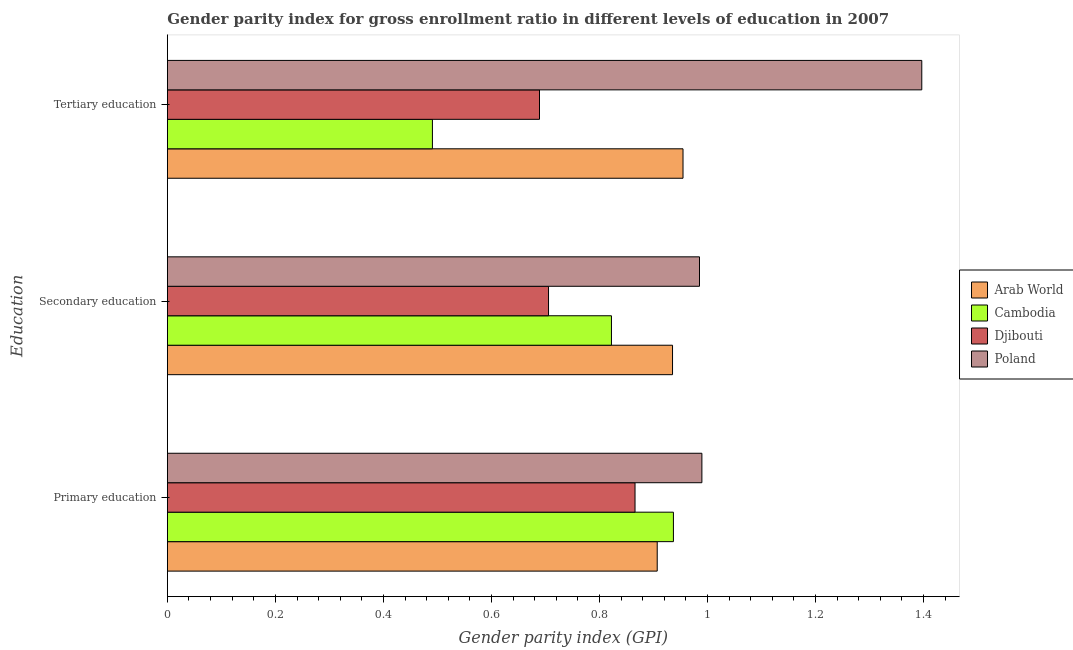How many different coloured bars are there?
Keep it short and to the point. 4. Are the number of bars on each tick of the Y-axis equal?
Provide a succinct answer. Yes. How many bars are there on the 2nd tick from the bottom?
Your response must be concise. 4. What is the label of the 2nd group of bars from the top?
Ensure brevity in your answer.  Secondary education. What is the gender parity index in primary education in Poland?
Ensure brevity in your answer.  0.99. Across all countries, what is the maximum gender parity index in tertiary education?
Provide a succinct answer. 1.4. Across all countries, what is the minimum gender parity index in tertiary education?
Ensure brevity in your answer.  0.49. In which country was the gender parity index in primary education maximum?
Provide a short and direct response. Poland. In which country was the gender parity index in primary education minimum?
Offer a very short reply. Djibouti. What is the total gender parity index in secondary education in the graph?
Make the answer very short. 3.45. What is the difference between the gender parity index in tertiary education in Djibouti and that in Poland?
Offer a terse response. -0.71. What is the difference between the gender parity index in tertiary education in Cambodia and the gender parity index in primary education in Djibouti?
Your answer should be compact. -0.38. What is the average gender parity index in primary education per country?
Offer a terse response. 0.92. What is the difference between the gender parity index in tertiary education and gender parity index in secondary education in Djibouti?
Ensure brevity in your answer.  -0.02. In how many countries, is the gender parity index in secondary education greater than 1.2400000000000002 ?
Your answer should be compact. 0. What is the ratio of the gender parity index in tertiary education in Cambodia to that in Poland?
Provide a succinct answer. 0.35. Is the gender parity index in primary education in Arab World less than that in Djibouti?
Provide a short and direct response. No. What is the difference between the highest and the second highest gender parity index in primary education?
Ensure brevity in your answer.  0.05. What is the difference between the highest and the lowest gender parity index in primary education?
Your answer should be compact. 0.12. In how many countries, is the gender parity index in primary education greater than the average gender parity index in primary education taken over all countries?
Keep it short and to the point. 2. What does the 3rd bar from the top in Primary education represents?
Ensure brevity in your answer.  Cambodia. What does the 1st bar from the bottom in Primary education represents?
Offer a terse response. Arab World. Is it the case that in every country, the sum of the gender parity index in primary education and gender parity index in secondary education is greater than the gender parity index in tertiary education?
Ensure brevity in your answer.  Yes. Does the graph contain any zero values?
Ensure brevity in your answer.  No. Does the graph contain grids?
Provide a short and direct response. No. How many legend labels are there?
Make the answer very short. 4. How are the legend labels stacked?
Provide a succinct answer. Vertical. What is the title of the graph?
Your answer should be compact. Gender parity index for gross enrollment ratio in different levels of education in 2007. What is the label or title of the X-axis?
Give a very brief answer. Gender parity index (GPI). What is the label or title of the Y-axis?
Your response must be concise. Education. What is the Gender parity index (GPI) of Arab World in Primary education?
Ensure brevity in your answer.  0.91. What is the Gender parity index (GPI) of Cambodia in Primary education?
Give a very brief answer. 0.94. What is the Gender parity index (GPI) in Djibouti in Primary education?
Provide a short and direct response. 0.87. What is the Gender parity index (GPI) in Poland in Primary education?
Your answer should be compact. 0.99. What is the Gender parity index (GPI) of Arab World in Secondary education?
Provide a succinct answer. 0.94. What is the Gender parity index (GPI) in Cambodia in Secondary education?
Your answer should be very brief. 0.82. What is the Gender parity index (GPI) of Djibouti in Secondary education?
Ensure brevity in your answer.  0.71. What is the Gender parity index (GPI) of Poland in Secondary education?
Your response must be concise. 0.99. What is the Gender parity index (GPI) of Arab World in Tertiary education?
Give a very brief answer. 0.95. What is the Gender parity index (GPI) of Cambodia in Tertiary education?
Provide a succinct answer. 0.49. What is the Gender parity index (GPI) of Djibouti in Tertiary education?
Ensure brevity in your answer.  0.69. What is the Gender parity index (GPI) of Poland in Tertiary education?
Give a very brief answer. 1.4. Across all Education, what is the maximum Gender parity index (GPI) in Arab World?
Give a very brief answer. 0.95. Across all Education, what is the maximum Gender parity index (GPI) of Cambodia?
Your response must be concise. 0.94. Across all Education, what is the maximum Gender parity index (GPI) of Djibouti?
Your response must be concise. 0.87. Across all Education, what is the maximum Gender parity index (GPI) in Poland?
Make the answer very short. 1.4. Across all Education, what is the minimum Gender parity index (GPI) in Arab World?
Provide a short and direct response. 0.91. Across all Education, what is the minimum Gender parity index (GPI) in Cambodia?
Provide a short and direct response. 0.49. Across all Education, what is the minimum Gender parity index (GPI) in Djibouti?
Ensure brevity in your answer.  0.69. Across all Education, what is the minimum Gender parity index (GPI) of Poland?
Ensure brevity in your answer.  0.99. What is the total Gender parity index (GPI) of Arab World in the graph?
Your answer should be very brief. 2.8. What is the total Gender parity index (GPI) in Cambodia in the graph?
Provide a succinct answer. 2.25. What is the total Gender parity index (GPI) in Djibouti in the graph?
Ensure brevity in your answer.  2.26. What is the total Gender parity index (GPI) in Poland in the graph?
Your answer should be very brief. 3.37. What is the difference between the Gender parity index (GPI) of Arab World in Primary education and that in Secondary education?
Ensure brevity in your answer.  -0.03. What is the difference between the Gender parity index (GPI) in Cambodia in Primary education and that in Secondary education?
Offer a terse response. 0.11. What is the difference between the Gender parity index (GPI) in Djibouti in Primary education and that in Secondary education?
Ensure brevity in your answer.  0.16. What is the difference between the Gender parity index (GPI) of Poland in Primary education and that in Secondary education?
Make the answer very short. 0. What is the difference between the Gender parity index (GPI) of Arab World in Primary education and that in Tertiary education?
Your response must be concise. -0.05. What is the difference between the Gender parity index (GPI) of Cambodia in Primary education and that in Tertiary education?
Your answer should be compact. 0.45. What is the difference between the Gender parity index (GPI) in Djibouti in Primary education and that in Tertiary education?
Make the answer very short. 0.18. What is the difference between the Gender parity index (GPI) of Poland in Primary education and that in Tertiary education?
Ensure brevity in your answer.  -0.41. What is the difference between the Gender parity index (GPI) in Arab World in Secondary education and that in Tertiary education?
Keep it short and to the point. -0.02. What is the difference between the Gender parity index (GPI) in Cambodia in Secondary education and that in Tertiary education?
Provide a succinct answer. 0.33. What is the difference between the Gender parity index (GPI) of Djibouti in Secondary education and that in Tertiary education?
Give a very brief answer. 0.02. What is the difference between the Gender parity index (GPI) of Poland in Secondary education and that in Tertiary education?
Your response must be concise. -0.41. What is the difference between the Gender parity index (GPI) in Arab World in Primary education and the Gender parity index (GPI) in Cambodia in Secondary education?
Your response must be concise. 0.08. What is the difference between the Gender parity index (GPI) in Arab World in Primary education and the Gender parity index (GPI) in Djibouti in Secondary education?
Offer a terse response. 0.2. What is the difference between the Gender parity index (GPI) of Arab World in Primary education and the Gender parity index (GPI) of Poland in Secondary education?
Keep it short and to the point. -0.08. What is the difference between the Gender parity index (GPI) in Cambodia in Primary education and the Gender parity index (GPI) in Djibouti in Secondary education?
Your answer should be very brief. 0.23. What is the difference between the Gender parity index (GPI) in Cambodia in Primary education and the Gender parity index (GPI) in Poland in Secondary education?
Your answer should be compact. -0.05. What is the difference between the Gender parity index (GPI) of Djibouti in Primary education and the Gender parity index (GPI) of Poland in Secondary education?
Make the answer very short. -0.12. What is the difference between the Gender parity index (GPI) of Arab World in Primary education and the Gender parity index (GPI) of Cambodia in Tertiary education?
Keep it short and to the point. 0.42. What is the difference between the Gender parity index (GPI) of Arab World in Primary education and the Gender parity index (GPI) of Djibouti in Tertiary education?
Provide a succinct answer. 0.22. What is the difference between the Gender parity index (GPI) in Arab World in Primary education and the Gender parity index (GPI) in Poland in Tertiary education?
Your answer should be compact. -0.49. What is the difference between the Gender parity index (GPI) of Cambodia in Primary education and the Gender parity index (GPI) of Djibouti in Tertiary education?
Make the answer very short. 0.25. What is the difference between the Gender parity index (GPI) of Cambodia in Primary education and the Gender parity index (GPI) of Poland in Tertiary education?
Your answer should be very brief. -0.46. What is the difference between the Gender parity index (GPI) in Djibouti in Primary education and the Gender parity index (GPI) in Poland in Tertiary education?
Your response must be concise. -0.53. What is the difference between the Gender parity index (GPI) of Arab World in Secondary education and the Gender parity index (GPI) of Cambodia in Tertiary education?
Offer a very short reply. 0.44. What is the difference between the Gender parity index (GPI) of Arab World in Secondary education and the Gender parity index (GPI) of Djibouti in Tertiary education?
Provide a succinct answer. 0.25. What is the difference between the Gender parity index (GPI) of Arab World in Secondary education and the Gender parity index (GPI) of Poland in Tertiary education?
Offer a very short reply. -0.46. What is the difference between the Gender parity index (GPI) in Cambodia in Secondary education and the Gender parity index (GPI) in Djibouti in Tertiary education?
Ensure brevity in your answer.  0.13. What is the difference between the Gender parity index (GPI) of Cambodia in Secondary education and the Gender parity index (GPI) of Poland in Tertiary education?
Your answer should be very brief. -0.57. What is the difference between the Gender parity index (GPI) of Djibouti in Secondary education and the Gender parity index (GPI) of Poland in Tertiary education?
Keep it short and to the point. -0.69. What is the average Gender parity index (GPI) in Arab World per Education?
Ensure brevity in your answer.  0.93. What is the average Gender parity index (GPI) in Cambodia per Education?
Your answer should be compact. 0.75. What is the average Gender parity index (GPI) in Djibouti per Education?
Provide a short and direct response. 0.75. What is the average Gender parity index (GPI) of Poland per Education?
Your response must be concise. 1.12. What is the difference between the Gender parity index (GPI) of Arab World and Gender parity index (GPI) of Cambodia in Primary education?
Give a very brief answer. -0.03. What is the difference between the Gender parity index (GPI) in Arab World and Gender parity index (GPI) in Djibouti in Primary education?
Keep it short and to the point. 0.04. What is the difference between the Gender parity index (GPI) of Arab World and Gender parity index (GPI) of Poland in Primary education?
Make the answer very short. -0.08. What is the difference between the Gender parity index (GPI) of Cambodia and Gender parity index (GPI) of Djibouti in Primary education?
Make the answer very short. 0.07. What is the difference between the Gender parity index (GPI) of Cambodia and Gender parity index (GPI) of Poland in Primary education?
Your answer should be compact. -0.05. What is the difference between the Gender parity index (GPI) of Djibouti and Gender parity index (GPI) of Poland in Primary education?
Keep it short and to the point. -0.12. What is the difference between the Gender parity index (GPI) of Arab World and Gender parity index (GPI) of Cambodia in Secondary education?
Give a very brief answer. 0.11. What is the difference between the Gender parity index (GPI) in Arab World and Gender parity index (GPI) in Djibouti in Secondary education?
Your answer should be very brief. 0.23. What is the difference between the Gender parity index (GPI) in Arab World and Gender parity index (GPI) in Poland in Secondary education?
Give a very brief answer. -0.05. What is the difference between the Gender parity index (GPI) of Cambodia and Gender parity index (GPI) of Djibouti in Secondary education?
Offer a terse response. 0.12. What is the difference between the Gender parity index (GPI) in Cambodia and Gender parity index (GPI) in Poland in Secondary education?
Ensure brevity in your answer.  -0.16. What is the difference between the Gender parity index (GPI) of Djibouti and Gender parity index (GPI) of Poland in Secondary education?
Ensure brevity in your answer.  -0.28. What is the difference between the Gender parity index (GPI) of Arab World and Gender parity index (GPI) of Cambodia in Tertiary education?
Ensure brevity in your answer.  0.46. What is the difference between the Gender parity index (GPI) of Arab World and Gender parity index (GPI) of Djibouti in Tertiary education?
Ensure brevity in your answer.  0.27. What is the difference between the Gender parity index (GPI) in Arab World and Gender parity index (GPI) in Poland in Tertiary education?
Provide a succinct answer. -0.44. What is the difference between the Gender parity index (GPI) of Cambodia and Gender parity index (GPI) of Djibouti in Tertiary education?
Your response must be concise. -0.2. What is the difference between the Gender parity index (GPI) of Cambodia and Gender parity index (GPI) of Poland in Tertiary education?
Keep it short and to the point. -0.91. What is the difference between the Gender parity index (GPI) in Djibouti and Gender parity index (GPI) in Poland in Tertiary education?
Offer a terse response. -0.71. What is the ratio of the Gender parity index (GPI) of Arab World in Primary education to that in Secondary education?
Make the answer very short. 0.97. What is the ratio of the Gender parity index (GPI) of Cambodia in Primary education to that in Secondary education?
Your response must be concise. 1.14. What is the ratio of the Gender parity index (GPI) in Djibouti in Primary education to that in Secondary education?
Your answer should be compact. 1.23. What is the ratio of the Gender parity index (GPI) in Poland in Primary education to that in Secondary education?
Your answer should be compact. 1. What is the ratio of the Gender parity index (GPI) of Cambodia in Primary education to that in Tertiary education?
Offer a terse response. 1.91. What is the ratio of the Gender parity index (GPI) of Djibouti in Primary education to that in Tertiary education?
Make the answer very short. 1.26. What is the ratio of the Gender parity index (GPI) of Poland in Primary education to that in Tertiary education?
Offer a very short reply. 0.71. What is the ratio of the Gender parity index (GPI) of Arab World in Secondary education to that in Tertiary education?
Keep it short and to the point. 0.98. What is the ratio of the Gender parity index (GPI) in Cambodia in Secondary education to that in Tertiary education?
Make the answer very short. 1.68. What is the ratio of the Gender parity index (GPI) in Djibouti in Secondary education to that in Tertiary education?
Your answer should be compact. 1.02. What is the ratio of the Gender parity index (GPI) in Poland in Secondary education to that in Tertiary education?
Make the answer very short. 0.71. What is the difference between the highest and the second highest Gender parity index (GPI) in Arab World?
Your answer should be compact. 0.02. What is the difference between the highest and the second highest Gender parity index (GPI) in Cambodia?
Give a very brief answer. 0.11. What is the difference between the highest and the second highest Gender parity index (GPI) in Djibouti?
Keep it short and to the point. 0.16. What is the difference between the highest and the second highest Gender parity index (GPI) in Poland?
Offer a terse response. 0.41. What is the difference between the highest and the lowest Gender parity index (GPI) of Arab World?
Provide a succinct answer. 0.05. What is the difference between the highest and the lowest Gender parity index (GPI) in Cambodia?
Provide a short and direct response. 0.45. What is the difference between the highest and the lowest Gender parity index (GPI) in Djibouti?
Make the answer very short. 0.18. What is the difference between the highest and the lowest Gender parity index (GPI) in Poland?
Offer a terse response. 0.41. 